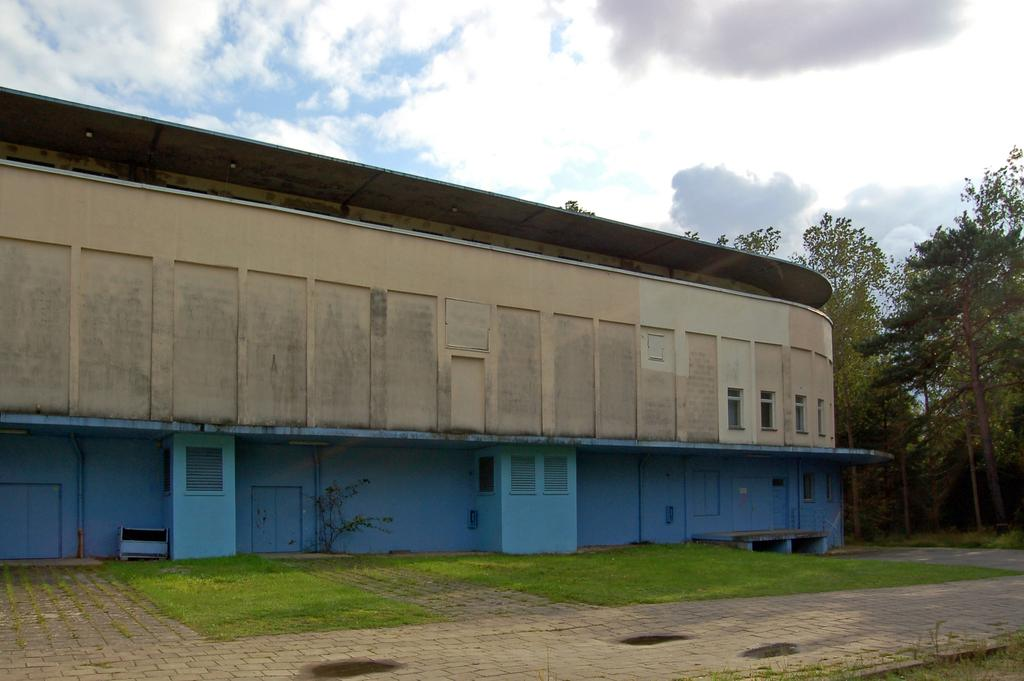What type of vegetation can be seen in the image? There is grass in the image. What kind of feature allows for walking or passage in the image? There is a path in the image. What structure separates or encloses areas in the image? There is a fence in the image. What type of tall plants are present in the image? There are trees in the image. What type of structure with openings for light and air is visible in the image? There is a building with windows in the image. What part of the natural environment is visible in the background of the image? The sky is visible in the background of the image. What atmospheric phenomena can be seen in the sky? There are clouds in the sky. Can you see the face of the person walking on the path in the image? There is no person walking on the path in the image, so it is not possible to see their face. How many chickens are visible in the image? There are no chickens present in the image. 